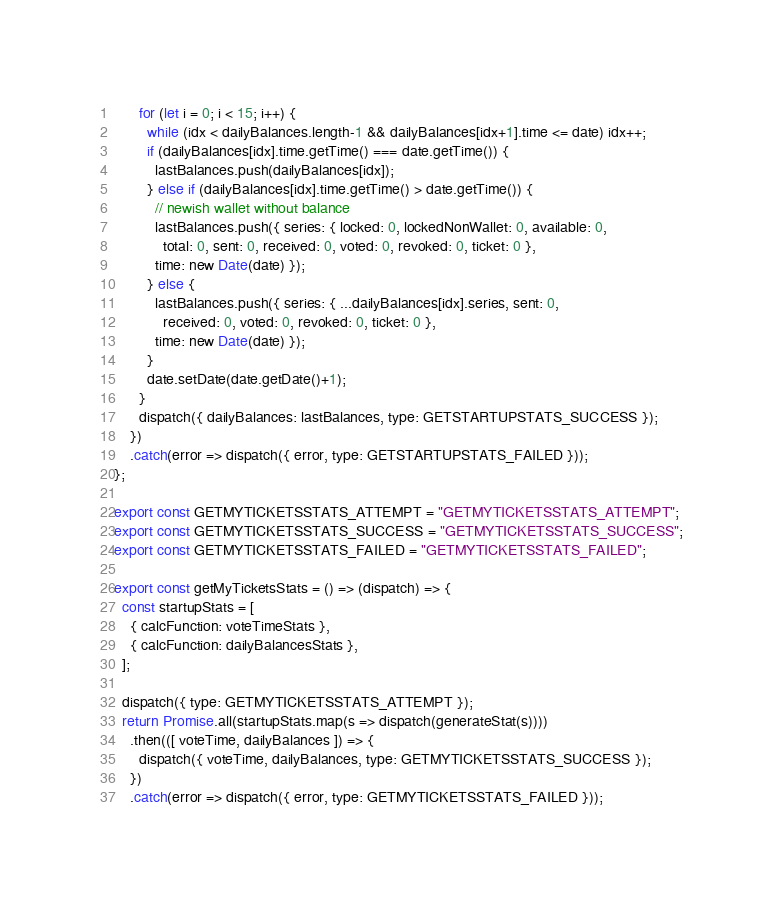Convert code to text. <code><loc_0><loc_0><loc_500><loc_500><_JavaScript_>      for (let i = 0; i < 15; i++) {
        while (idx < dailyBalances.length-1 && dailyBalances[idx+1].time <= date) idx++;
        if (dailyBalances[idx].time.getTime() === date.getTime()) {
          lastBalances.push(dailyBalances[idx]);
        } else if (dailyBalances[idx].time.getTime() > date.getTime()) {
          // newish wallet without balance
          lastBalances.push({ series: { locked: 0, lockedNonWallet: 0, available: 0,
            total: 0, sent: 0, received: 0, voted: 0, revoked: 0, ticket: 0 },
          time: new Date(date) });
        } else {
          lastBalances.push({ series: { ...dailyBalances[idx].series, sent: 0,
            received: 0, voted: 0, revoked: 0, ticket: 0 },
          time: new Date(date) });
        }
        date.setDate(date.getDate()+1);
      }
      dispatch({ dailyBalances: lastBalances, type: GETSTARTUPSTATS_SUCCESS });
    })
    .catch(error => dispatch({ error, type: GETSTARTUPSTATS_FAILED }));
};

export const GETMYTICKETSSTATS_ATTEMPT = "GETMYTICKETSSTATS_ATTEMPT";
export const GETMYTICKETSSTATS_SUCCESS = "GETMYTICKETSSTATS_SUCCESS";
export const GETMYTICKETSSTATS_FAILED = "GETMYTICKETSSTATS_FAILED";

export const getMyTicketsStats = () => (dispatch) => {
  const startupStats = [
    { calcFunction: voteTimeStats },
    { calcFunction: dailyBalancesStats },
  ];

  dispatch({ type: GETMYTICKETSSTATS_ATTEMPT });
  return Promise.all(startupStats.map(s => dispatch(generateStat(s))))
    .then(([ voteTime, dailyBalances ]) => {
      dispatch({ voteTime, dailyBalances, type: GETMYTICKETSSTATS_SUCCESS });
    })
    .catch(error => dispatch({ error, type: GETMYTICKETSSTATS_FAILED }));</code> 